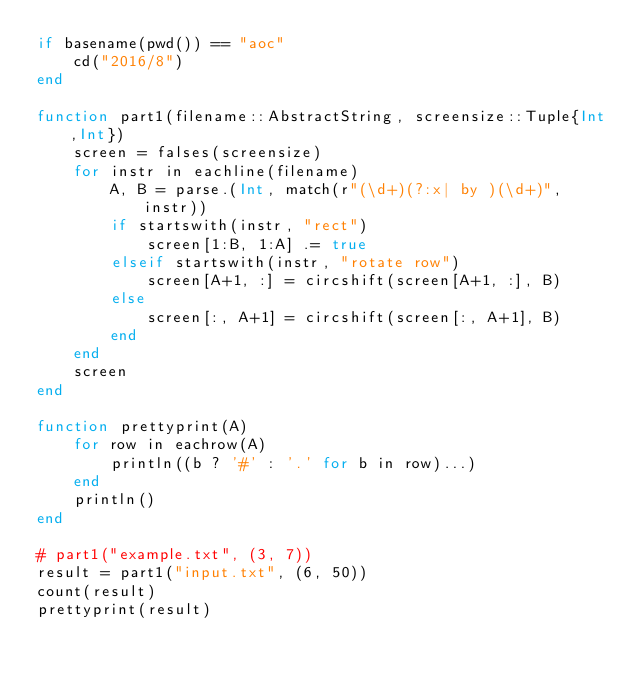Convert code to text. <code><loc_0><loc_0><loc_500><loc_500><_Julia_>if basename(pwd()) == "aoc"
    cd("2016/8")
end

function part1(filename::AbstractString, screensize::Tuple{Int,Int})
    screen = falses(screensize)
    for instr in eachline(filename)
        A, B = parse.(Int, match(r"(\d+)(?:x| by )(\d+)", instr))
        if startswith(instr, "rect")
            screen[1:B, 1:A] .= true
        elseif startswith(instr, "rotate row")
            screen[A+1, :] = circshift(screen[A+1, :], B)
        else
            screen[:, A+1] = circshift(screen[:, A+1], B)
        end
    end
    screen
end

function prettyprint(A)
    for row in eachrow(A)
        println((b ? '#' : '.' for b in row)...)
    end
    println()
end

# part1("example.txt", (3, 7))
result = part1("input.txt", (6, 50))
count(result)
prettyprint(result)
</code> 